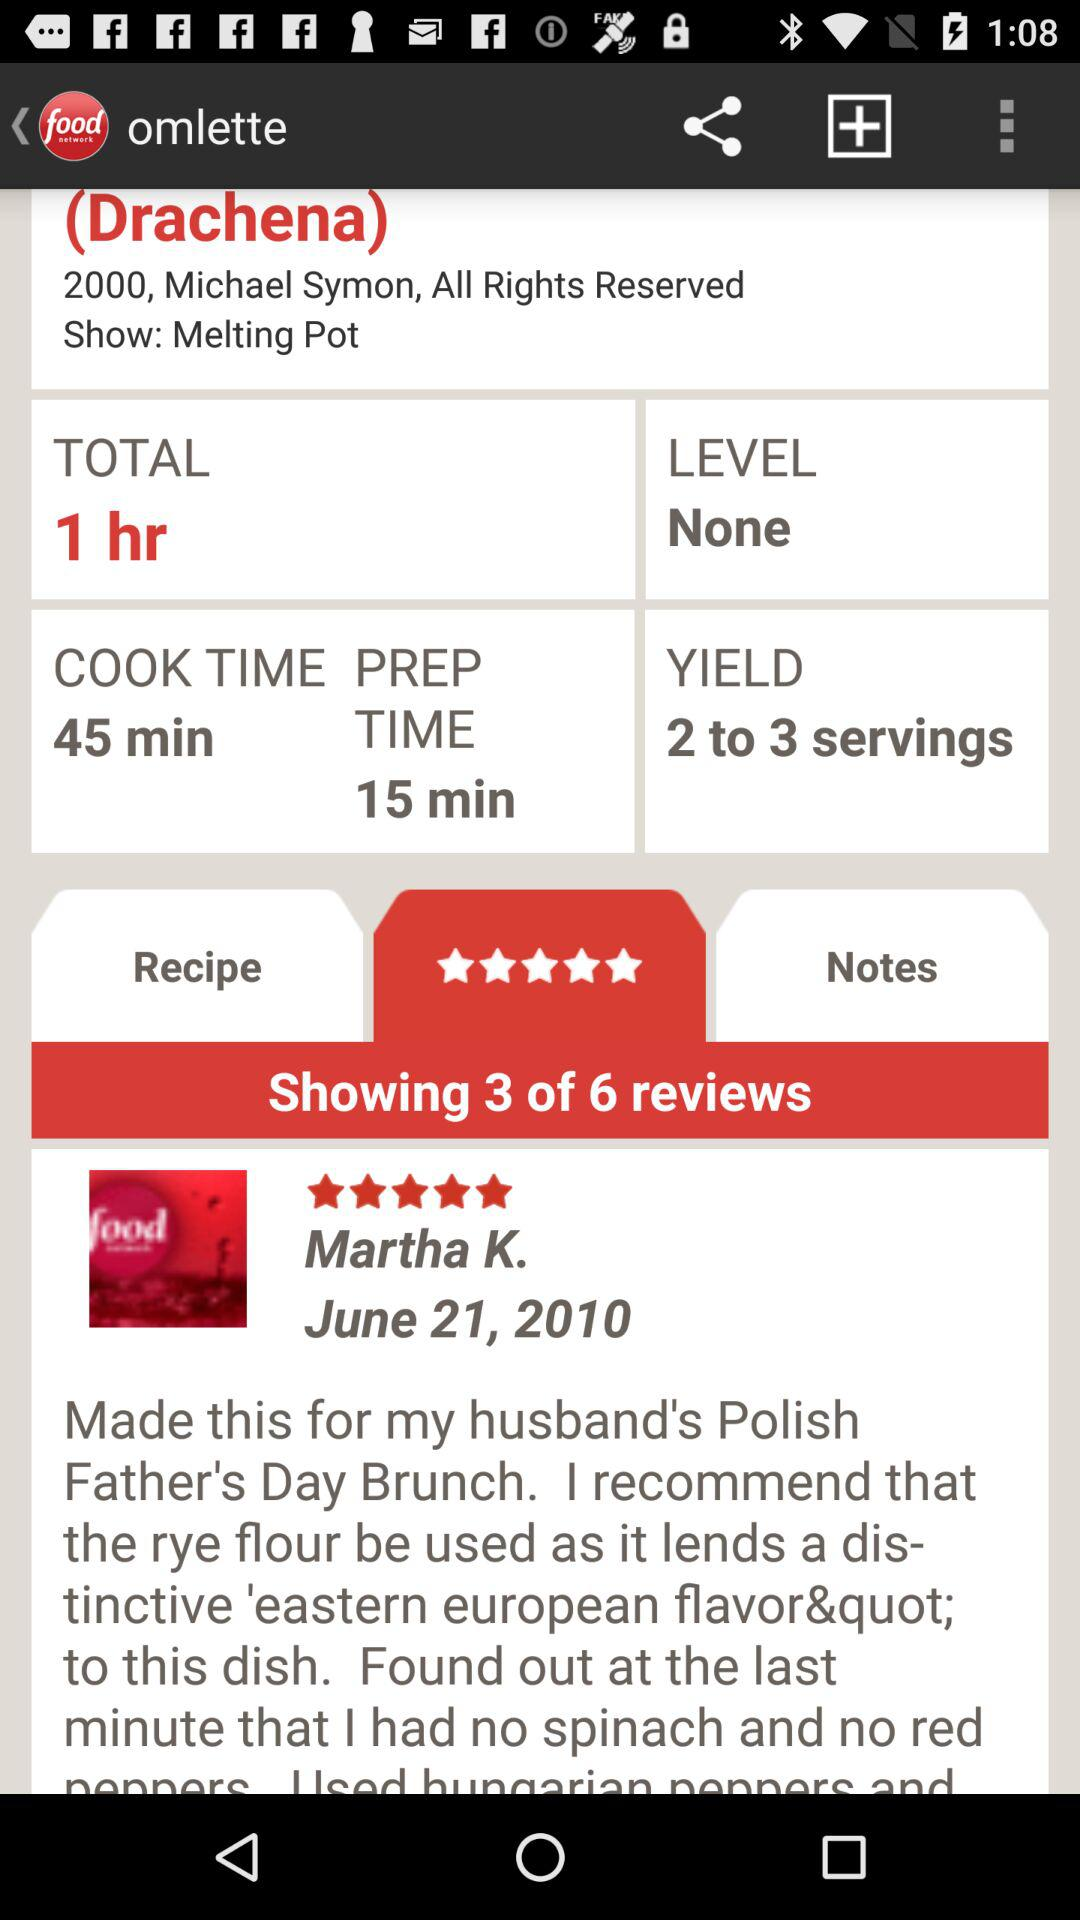On what date did Martha K. post the review? Martha K. posted the review on June 21, 2010. 